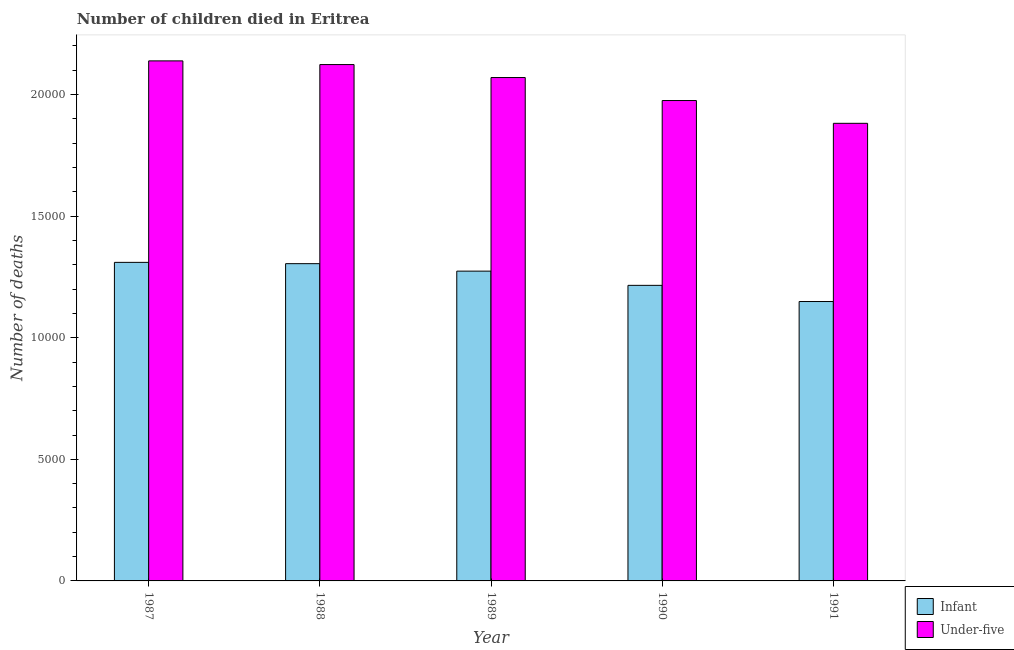How many groups of bars are there?
Your response must be concise. 5. How many bars are there on the 5th tick from the left?
Give a very brief answer. 2. In how many cases, is the number of bars for a given year not equal to the number of legend labels?
Make the answer very short. 0. What is the number of infant deaths in 1987?
Make the answer very short. 1.31e+04. Across all years, what is the maximum number of infant deaths?
Ensure brevity in your answer.  1.31e+04. Across all years, what is the minimum number of under-five deaths?
Offer a very short reply. 1.88e+04. In which year was the number of infant deaths minimum?
Give a very brief answer. 1991. What is the total number of under-five deaths in the graph?
Provide a short and direct response. 1.02e+05. What is the difference between the number of infant deaths in 1989 and that in 1991?
Offer a very short reply. 1250. What is the difference between the number of infant deaths in 1990 and the number of under-five deaths in 1988?
Your response must be concise. -892. What is the average number of infant deaths per year?
Offer a very short reply. 1.25e+04. In the year 1989, what is the difference between the number of under-five deaths and number of infant deaths?
Your response must be concise. 0. In how many years, is the number of under-five deaths greater than 17000?
Give a very brief answer. 5. What is the ratio of the number of under-five deaths in 1988 to that in 1989?
Offer a very short reply. 1.03. Is the number of infant deaths in 1988 less than that in 1990?
Offer a very short reply. No. Is the difference between the number of infant deaths in 1989 and 1990 greater than the difference between the number of under-five deaths in 1989 and 1990?
Offer a very short reply. No. What is the difference between the highest and the second highest number of under-five deaths?
Provide a short and direct response. 152. What is the difference between the highest and the lowest number of under-five deaths?
Offer a very short reply. 2568. What does the 2nd bar from the left in 1991 represents?
Your answer should be very brief. Under-five. What does the 2nd bar from the right in 1988 represents?
Your answer should be very brief. Infant. How many years are there in the graph?
Keep it short and to the point. 5. Are the values on the major ticks of Y-axis written in scientific E-notation?
Provide a short and direct response. No. Where does the legend appear in the graph?
Provide a short and direct response. Bottom right. How are the legend labels stacked?
Your answer should be very brief. Vertical. What is the title of the graph?
Your answer should be compact. Number of children died in Eritrea. What is the label or title of the Y-axis?
Make the answer very short. Number of deaths. What is the Number of deaths in Infant in 1987?
Offer a very short reply. 1.31e+04. What is the Number of deaths in Under-five in 1987?
Give a very brief answer. 2.14e+04. What is the Number of deaths in Infant in 1988?
Your response must be concise. 1.30e+04. What is the Number of deaths in Under-five in 1988?
Make the answer very short. 2.12e+04. What is the Number of deaths in Infant in 1989?
Offer a terse response. 1.27e+04. What is the Number of deaths of Under-five in 1989?
Your answer should be very brief. 2.07e+04. What is the Number of deaths of Infant in 1990?
Keep it short and to the point. 1.22e+04. What is the Number of deaths in Under-five in 1990?
Offer a very short reply. 1.98e+04. What is the Number of deaths of Infant in 1991?
Ensure brevity in your answer.  1.15e+04. What is the Number of deaths in Under-five in 1991?
Provide a short and direct response. 1.88e+04. Across all years, what is the maximum Number of deaths of Infant?
Ensure brevity in your answer.  1.31e+04. Across all years, what is the maximum Number of deaths in Under-five?
Your answer should be very brief. 2.14e+04. Across all years, what is the minimum Number of deaths of Infant?
Your answer should be compact. 1.15e+04. Across all years, what is the minimum Number of deaths of Under-five?
Offer a terse response. 1.88e+04. What is the total Number of deaths in Infant in the graph?
Your answer should be compact. 6.25e+04. What is the total Number of deaths in Under-five in the graph?
Give a very brief answer. 1.02e+05. What is the difference between the Number of deaths of Infant in 1987 and that in 1988?
Offer a very short reply. 53. What is the difference between the Number of deaths in Under-five in 1987 and that in 1988?
Provide a succinct answer. 152. What is the difference between the Number of deaths of Infant in 1987 and that in 1989?
Your answer should be very brief. 360. What is the difference between the Number of deaths of Under-five in 1987 and that in 1989?
Make the answer very short. 685. What is the difference between the Number of deaths in Infant in 1987 and that in 1990?
Keep it short and to the point. 945. What is the difference between the Number of deaths in Under-five in 1987 and that in 1990?
Your answer should be very brief. 1631. What is the difference between the Number of deaths in Infant in 1987 and that in 1991?
Your answer should be very brief. 1610. What is the difference between the Number of deaths in Under-five in 1987 and that in 1991?
Make the answer very short. 2568. What is the difference between the Number of deaths in Infant in 1988 and that in 1989?
Make the answer very short. 307. What is the difference between the Number of deaths of Under-five in 1988 and that in 1989?
Offer a very short reply. 533. What is the difference between the Number of deaths of Infant in 1988 and that in 1990?
Offer a very short reply. 892. What is the difference between the Number of deaths in Under-five in 1988 and that in 1990?
Ensure brevity in your answer.  1479. What is the difference between the Number of deaths in Infant in 1988 and that in 1991?
Offer a terse response. 1557. What is the difference between the Number of deaths in Under-five in 1988 and that in 1991?
Your response must be concise. 2416. What is the difference between the Number of deaths of Infant in 1989 and that in 1990?
Provide a short and direct response. 585. What is the difference between the Number of deaths of Under-five in 1989 and that in 1990?
Provide a short and direct response. 946. What is the difference between the Number of deaths in Infant in 1989 and that in 1991?
Provide a short and direct response. 1250. What is the difference between the Number of deaths in Under-five in 1989 and that in 1991?
Offer a terse response. 1883. What is the difference between the Number of deaths of Infant in 1990 and that in 1991?
Offer a very short reply. 665. What is the difference between the Number of deaths in Under-five in 1990 and that in 1991?
Your response must be concise. 937. What is the difference between the Number of deaths of Infant in 1987 and the Number of deaths of Under-five in 1988?
Give a very brief answer. -8135. What is the difference between the Number of deaths in Infant in 1987 and the Number of deaths in Under-five in 1989?
Provide a succinct answer. -7602. What is the difference between the Number of deaths of Infant in 1987 and the Number of deaths of Under-five in 1990?
Keep it short and to the point. -6656. What is the difference between the Number of deaths of Infant in 1987 and the Number of deaths of Under-five in 1991?
Your answer should be very brief. -5719. What is the difference between the Number of deaths of Infant in 1988 and the Number of deaths of Under-five in 1989?
Ensure brevity in your answer.  -7655. What is the difference between the Number of deaths of Infant in 1988 and the Number of deaths of Under-five in 1990?
Give a very brief answer. -6709. What is the difference between the Number of deaths of Infant in 1988 and the Number of deaths of Under-five in 1991?
Provide a succinct answer. -5772. What is the difference between the Number of deaths of Infant in 1989 and the Number of deaths of Under-five in 1990?
Your response must be concise. -7016. What is the difference between the Number of deaths of Infant in 1989 and the Number of deaths of Under-five in 1991?
Give a very brief answer. -6079. What is the difference between the Number of deaths in Infant in 1990 and the Number of deaths in Under-five in 1991?
Ensure brevity in your answer.  -6664. What is the average Number of deaths of Infant per year?
Give a very brief answer. 1.25e+04. What is the average Number of deaths in Under-five per year?
Your answer should be compact. 2.04e+04. In the year 1987, what is the difference between the Number of deaths of Infant and Number of deaths of Under-five?
Provide a short and direct response. -8287. In the year 1988, what is the difference between the Number of deaths in Infant and Number of deaths in Under-five?
Your answer should be compact. -8188. In the year 1989, what is the difference between the Number of deaths of Infant and Number of deaths of Under-five?
Provide a succinct answer. -7962. In the year 1990, what is the difference between the Number of deaths in Infant and Number of deaths in Under-five?
Your response must be concise. -7601. In the year 1991, what is the difference between the Number of deaths of Infant and Number of deaths of Under-five?
Offer a terse response. -7329. What is the ratio of the Number of deaths in Infant in 1987 to that in 1989?
Make the answer very short. 1.03. What is the ratio of the Number of deaths of Under-five in 1987 to that in 1989?
Offer a very short reply. 1.03. What is the ratio of the Number of deaths of Infant in 1987 to that in 1990?
Provide a short and direct response. 1.08. What is the ratio of the Number of deaths of Under-five in 1987 to that in 1990?
Provide a short and direct response. 1.08. What is the ratio of the Number of deaths in Infant in 1987 to that in 1991?
Ensure brevity in your answer.  1.14. What is the ratio of the Number of deaths in Under-five in 1987 to that in 1991?
Ensure brevity in your answer.  1.14. What is the ratio of the Number of deaths of Infant in 1988 to that in 1989?
Offer a terse response. 1.02. What is the ratio of the Number of deaths in Under-five in 1988 to that in 1989?
Offer a very short reply. 1.03. What is the ratio of the Number of deaths in Infant in 1988 to that in 1990?
Offer a terse response. 1.07. What is the ratio of the Number of deaths of Under-five in 1988 to that in 1990?
Keep it short and to the point. 1.07. What is the ratio of the Number of deaths in Infant in 1988 to that in 1991?
Ensure brevity in your answer.  1.14. What is the ratio of the Number of deaths of Under-five in 1988 to that in 1991?
Your response must be concise. 1.13. What is the ratio of the Number of deaths in Infant in 1989 to that in 1990?
Ensure brevity in your answer.  1.05. What is the ratio of the Number of deaths in Under-five in 1989 to that in 1990?
Provide a succinct answer. 1.05. What is the ratio of the Number of deaths of Infant in 1989 to that in 1991?
Your answer should be compact. 1.11. What is the ratio of the Number of deaths in Under-five in 1989 to that in 1991?
Your answer should be very brief. 1.1. What is the ratio of the Number of deaths in Infant in 1990 to that in 1991?
Ensure brevity in your answer.  1.06. What is the ratio of the Number of deaths of Under-five in 1990 to that in 1991?
Keep it short and to the point. 1.05. What is the difference between the highest and the second highest Number of deaths in Under-five?
Provide a succinct answer. 152. What is the difference between the highest and the lowest Number of deaths in Infant?
Your answer should be very brief. 1610. What is the difference between the highest and the lowest Number of deaths in Under-five?
Your response must be concise. 2568. 